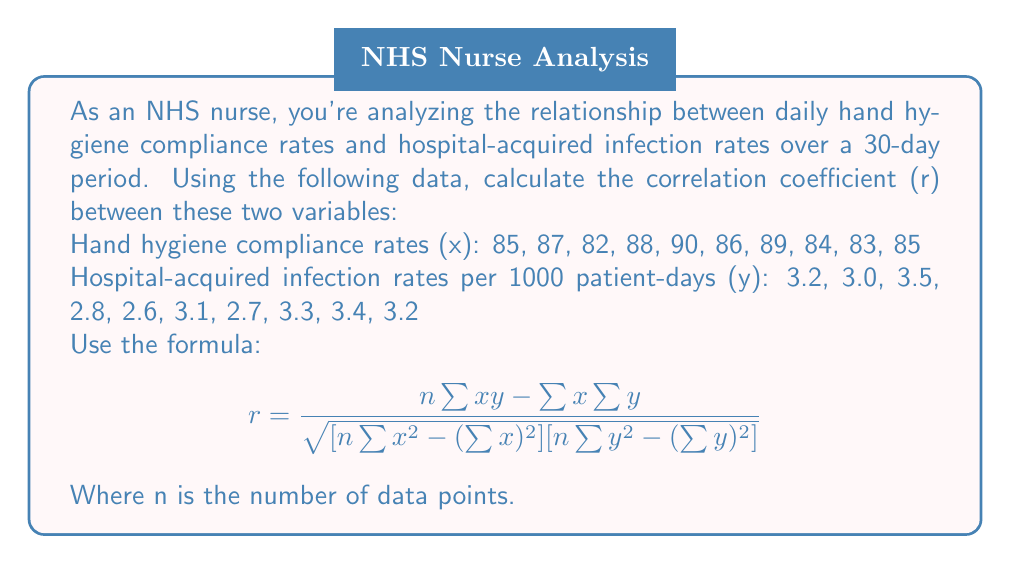What is the answer to this math problem? To calculate the correlation coefficient, we'll follow these steps:

1) First, let's calculate the necessary sums:
   $n = 10$ (number of data points)
   $\sum x = 859$
   $\sum y = 30.8$
   $\sum xy = 2636.3$
   $\sum x^2 = 73,805$
   $\sum y^2 = 95.54$

2) Now, let's substitute these values into the formula:

   $r = \frac{10(2636.3) - (859)(30.8)}{\sqrt{[10(73,805) - (859)^2][10(95.54) - (30.8)^2]}}$

3) Let's calculate the numerator:
   $10(2636.3) - (859)(30.8) = 26,363 - 26,457.2 = -94.2$

4) Now, let's calculate the denominator:
   $10(73,805) - (859)^2 = 738,050 - 737,881 = 169$
   $10(95.54) - (30.8)^2 = 955.4 - 948.64 = 6.76$
   $\sqrt{(169)(6.76)} = \sqrt{1142.44} = 33.80$

5) Putting it all together:
   $r = \frac{-94.2}{33.80} = -2.787$

6) Rounding to 3 decimal places:
   $r \approx -0.979$
Answer: $r \approx -0.979$ 